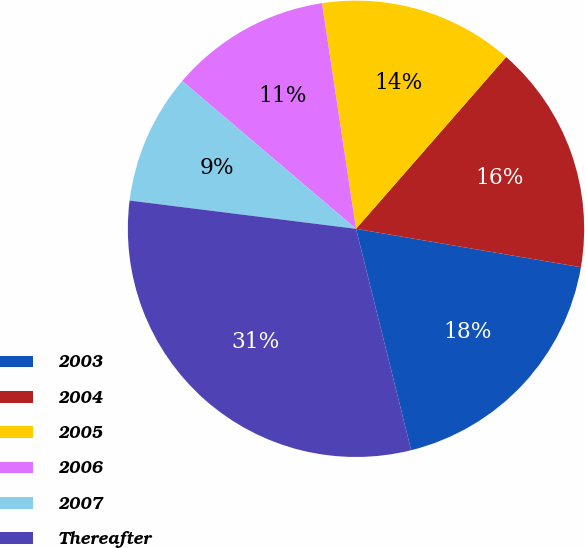Convert chart. <chart><loc_0><loc_0><loc_500><loc_500><pie_chart><fcel>2003<fcel>2004<fcel>2005<fcel>2006<fcel>2007<fcel>Thereafter<nl><fcel>18.42%<fcel>16.26%<fcel>13.81%<fcel>11.4%<fcel>9.24%<fcel>30.86%<nl></chart> 